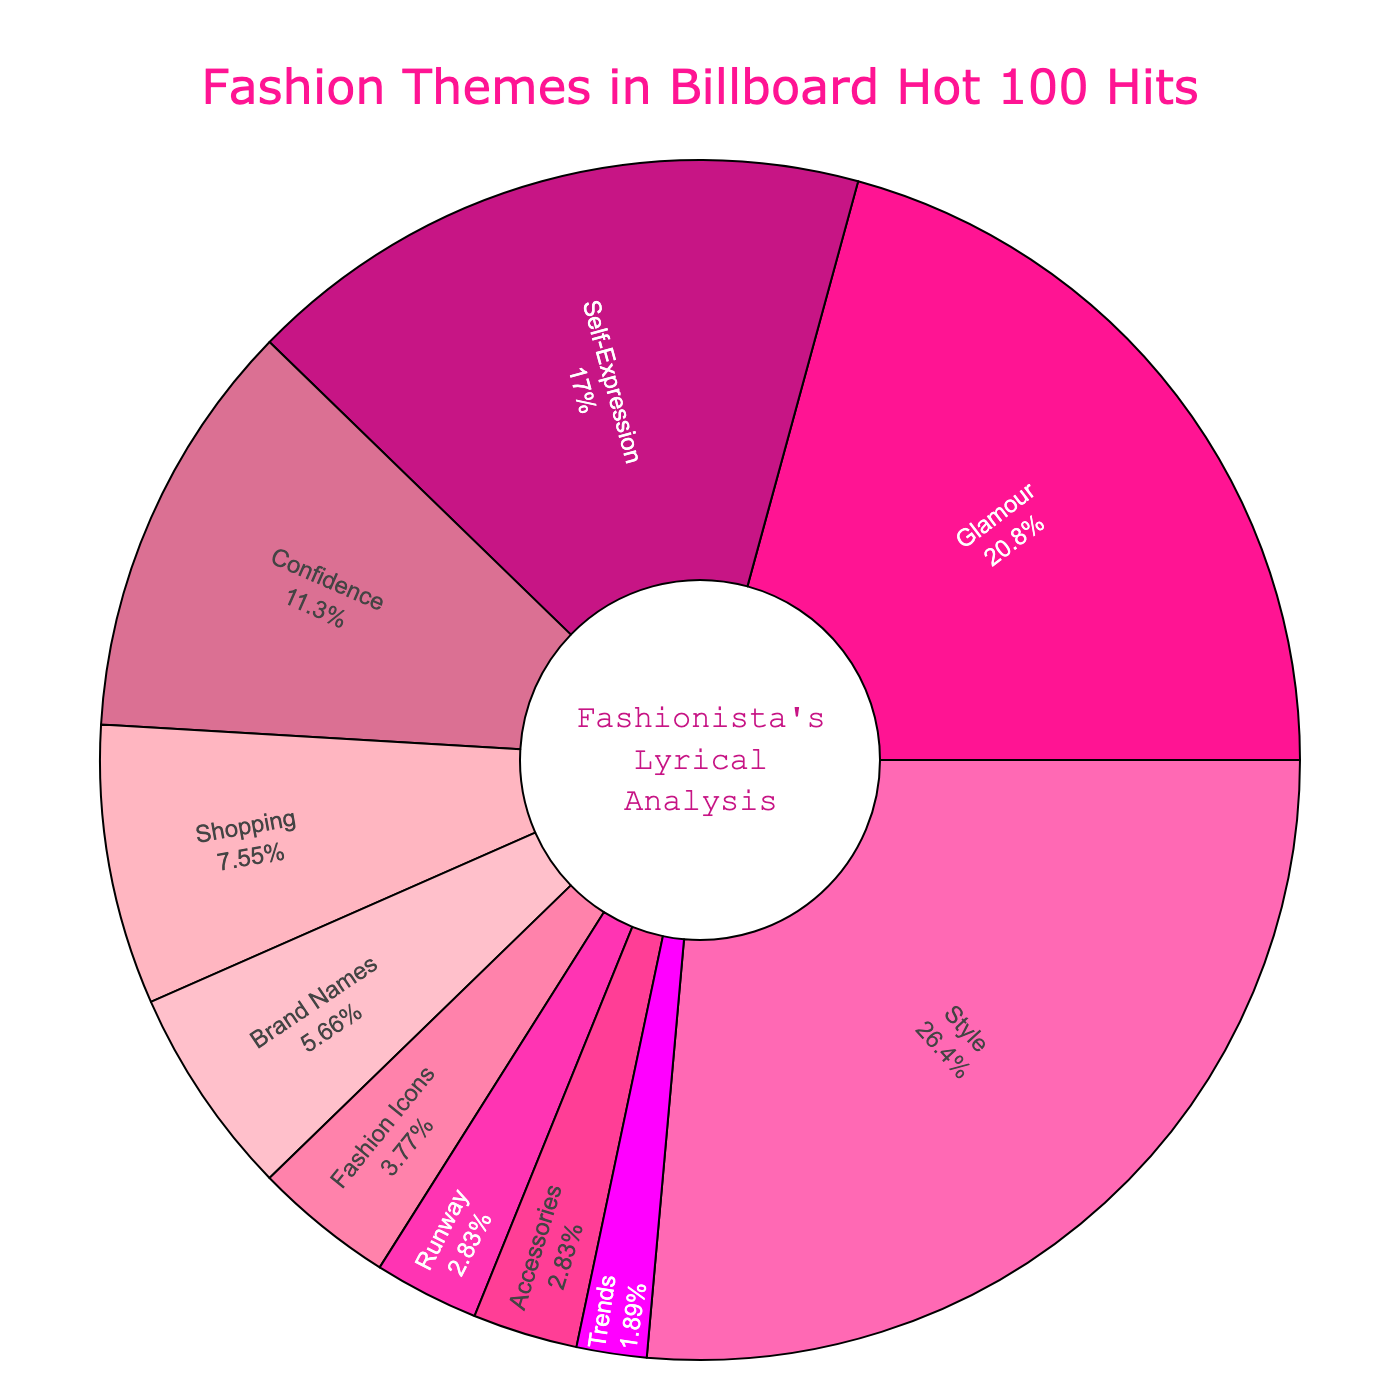What's the largest theme category in the chart? The pie chart shows different proportions for each theme. The largest percentage is 28%, which corresponds to the theme "Style".
Answer: Style What is the combined percentage of "Shopping" and "Brand Names"? "Shopping" is 8% and "Brand Names" is 6%. Adding these together gives 8 + 6 = 14%.
Answer: 14% How many themes have a percentage greater than 10%? From the pie chart, the themes "Style" (28%), "Glamour" (22%), "Self-Expression" (18%), and "Confidence" (12%) each have a percentage greater than 10%. That makes a total of 4 themes.
Answer: 4 Which theme has the smallest percentage, and what is it? The pie chart shows the smallest slices. "Trends" is the smallest with a percentage of 2%.
Answer: Trends, 2% Are there any themes that share the same percentage? If so, which ones? The pie chart indicates that "Runway" and "Accessories" each have a percentage of 3%.
Answer: Runway and Accessories Is the percentage of "Self-Expression" more than double that of "Accessories"? "Self-Expression" is 18% and "Accessories" is 3%. 18 is indeed more than double 3 (double 3 is 6).
Answer: Yes What is the difference in percentage points between "Style" and "Glamour"? "Style" has 28% and "Glamour" has 22%. The difference between these two percentages is 28 - 22 = 6%.
Answer: 6% Which theme has more presence: "Fashion Icons" or "Runway"? The pie chart shows "Fashion Icons" at 4% and "Runway" at 3%. Therefore, "Fashion Icons" has more presence.
Answer: Fashion Icons What is the total percentage of themes related to "Runway," "Accessories," and "Trends"? The percentages for "Runway" is 3%, "Accessories" is 3%, and "Trends" is 2%. Adding these gives 3 + 3 + 2 = 8%.
Answer: 8% Which theme comes immediately after "Confidence" when sorting by percentage in descending order? In descending order by percentage, the themes are "Style" (28%), "Glamour" (22%), "Self-Expression" (18%), and "Confidence" (12%). After "Confidence", the next highest theme is "Shopping" with 8%.
Answer: Shopping 